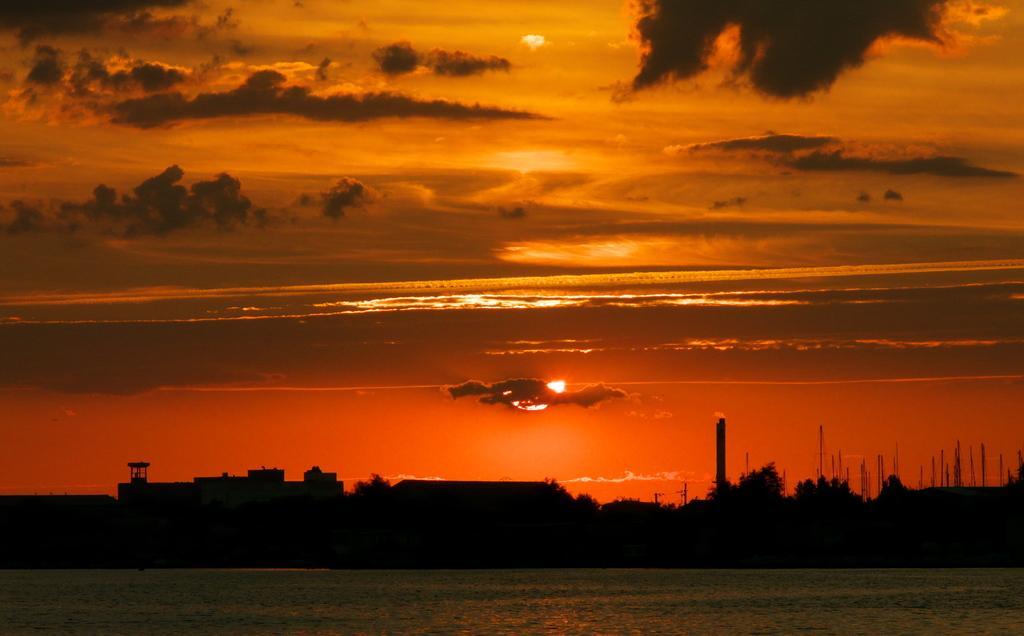In one or two sentences, can you explain what this image depicts? In the center of the image we can see the buildings, trees and poles. At the top of the image we can see the sun and clouds are present in the sky. At the bottom of the image we can see the water. 